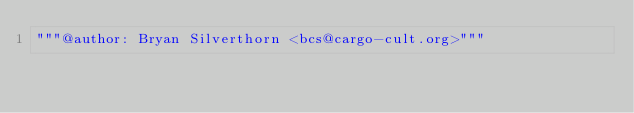Convert code to text. <code><loc_0><loc_0><loc_500><loc_500><_Cython_>"""@author: Bryan Silverthorn <bcs@cargo-cult.org>"""

</code> 